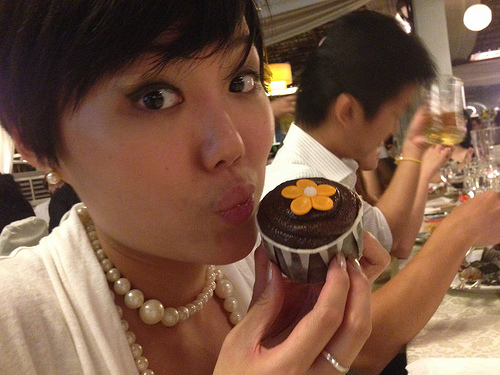Which color is the flower? The flower is orange in color. 